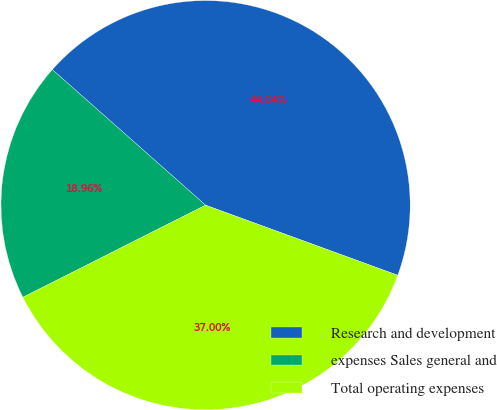Convert chart to OTSL. <chart><loc_0><loc_0><loc_500><loc_500><pie_chart><fcel>Research and development<fcel>expenses Sales general and<fcel>Total operating expenses<nl><fcel>44.04%<fcel>18.96%<fcel>37.0%<nl></chart> 